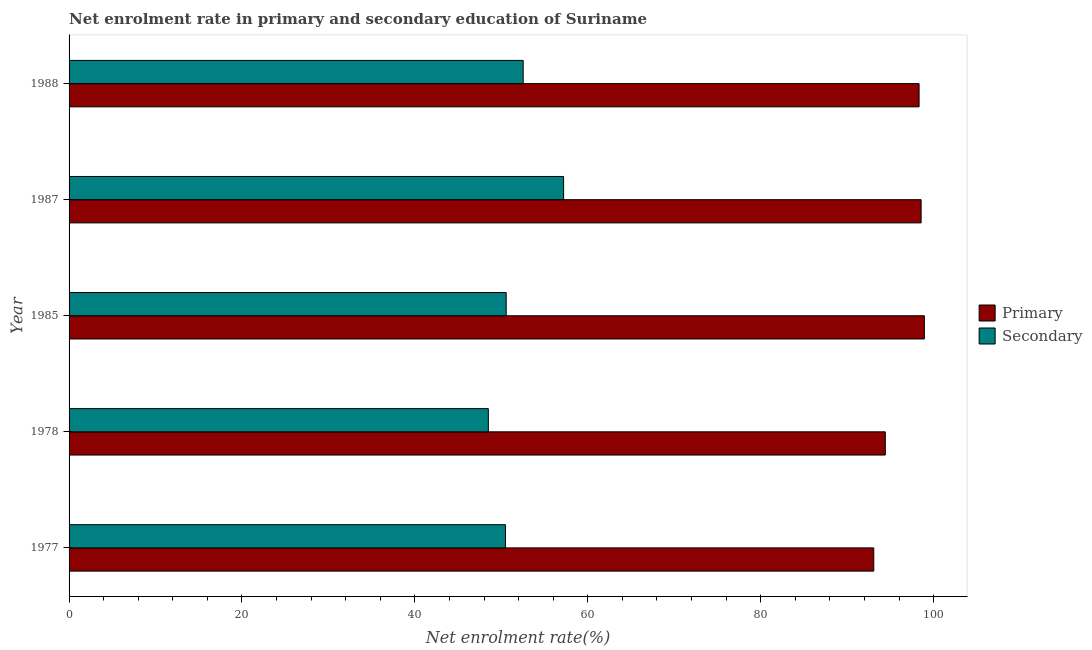How many groups of bars are there?
Provide a succinct answer. 5. Are the number of bars per tick equal to the number of legend labels?
Your answer should be compact. Yes. Are the number of bars on each tick of the Y-axis equal?
Ensure brevity in your answer.  Yes. How many bars are there on the 5th tick from the top?
Make the answer very short. 2. In how many cases, is the number of bars for a given year not equal to the number of legend labels?
Keep it short and to the point. 0. What is the enrollment rate in primary education in 1977?
Provide a short and direct response. 93.08. Across all years, what is the maximum enrollment rate in secondary education?
Offer a very short reply. 57.2. Across all years, what is the minimum enrollment rate in secondary education?
Offer a very short reply. 48.5. In which year was the enrollment rate in primary education minimum?
Your answer should be compact. 1977. What is the total enrollment rate in secondary education in the graph?
Ensure brevity in your answer.  259.26. What is the difference between the enrollment rate in secondary education in 1987 and that in 1988?
Your answer should be very brief. 4.67. What is the difference between the enrollment rate in primary education in 1978 and the enrollment rate in secondary education in 1977?
Offer a terse response. 43.94. What is the average enrollment rate in secondary education per year?
Your answer should be compact. 51.85. In the year 1977, what is the difference between the enrollment rate in secondary education and enrollment rate in primary education?
Ensure brevity in your answer.  -42.6. In how many years, is the enrollment rate in secondary education greater than 8 %?
Your response must be concise. 5. What is the ratio of the enrollment rate in secondary education in 1977 to that in 1978?
Make the answer very short. 1.04. What is the difference between the highest and the second highest enrollment rate in primary education?
Provide a succinct answer. 0.38. What is the difference between the highest and the lowest enrollment rate in secondary education?
Give a very brief answer. 8.71. What does the 2nd bar from the top in 1987 represents?
Provide a succinct answer. Primary. What does the 1st bar from the bottom in 1985 represents?
Make the answer very short. Primary. Are all the bars in the graph horizontal?
Provide a short and direct response. Yes. How many years are there in the graph?
Your answer should be compact. 5. What is the difference between two consecutive major ticks on the X-axis?
Make the answer very short. 20. Are the values on the major ticks of X-axis written in scientific E-notation?
Offer a very short reply. No. Does the graph contain any zero values?
Provide a short and direct response. No. What is the title of the graph?
Your answer should be very brief. Net enrolment rate in primary and secondary education of Suriname. Does "Secondary Education" appear as one of the legend labels in the graph?
Your answer should be very brief. No. What is the label or title of the X-axis?
Provide a succinct answer. Net enrolment rate(%). What is the label or title of the Y-axis?
Your answer should be very brief. Year. What is the Net enrolment rate(%) of Primary in 1977?
Ensure brevity in your answer.  93.08. What is the Net enrolment rate(%) in Secondary in 1977?
Offer a very short reply. 50.47. What is the Net enrolment rate(%) of Primary in 1978?
Provide a short and direct response. 94.41. What is the Net enrolment rate(%) in Secondary in 1978?
Give a very brief answer. 48.5. What is the Net enrolment rate(%) in Primary in 1985?
Provide a succinct answer. 98.93. What is the Net enrolment rate(%) of Secondary in 1985?
Your answer should be very brief. 50.56. What is the Net enrolment rate(%) in Primary in 1987?
Give a very brief answer. 98.55. What is the Net enrolment rate(%) of Secondary in 1987?
Your answer should be very brief. 57.2. What is the Net enrolment rate(%) of Primary in 1988?
Offer a very short reply. 98.32. What is the Net enrolment rate(%) of Secondary in 1988?
Provide a short and direct response. 52.53. Across all years, what is the maximum Net enrolment rate(%) in Primary?
Provide a succinct answer. 98.93. Across all years, what is the maximum Net enrolment rate(%) in Secondary?
Make the answer very short. 57.2. Across all years, what is the minimum Net enrolment rate(%) of Primary?
Make the answer very short. 93.08. Across all years, what is the minimum Net enrolment rate(%) of Secondary?
Your answer should be very brief. 48.5. What is the total Net enrolment rate(%) of Primary in the graph?
Give a very brief answer. 483.28. What is the total Net enrolment rate(%) of Secondary in the graph?
Keep it short and to the point. 259.26. What is the difference between the Net enrolment rate(%) in Primary in 1977 and that in 1978?
Your answer should be very brief. -1.34. What is the difference between the Net enrolment rate(%) in Secondary in 1977 and that in 1978?
Give a very brief answer. 1.98. What is the difference between the Net enrolment rate(%) of Primary in 1977 and that in 1985?
Ensure brevity in your answer.  -5.85. What is the difference between the Net enrolment rate(%) of Secondary in 1977 and that in 1985?
Make the answer very short. -0.09. What is the difference between the Net enrolment rate(%) of Primary in 1977 and that in 1987?
Provide a succinct answer. -5.48. What is the difference between the Net enrolment rate(%) in Secondary in 1977 and that in 1987?
Ensure brevity in your answer.  -6.73. What is the difference between the Net enrolment rate(%) in Primary in 1977 and that in 1988?
Give a very brief answer. -5.24. What is the difference between the Net enrolment rate(%) in Secondary in 1977 and that in 1988?
Give a very brief answer. -2.05. What is the difference between the Net enrolment rate(%) of Primary in 1978 and that in 1985?
Give a very brief answer. -4.52. What is the difference between the Net enrolment rate(%) of Secondary in 1978 and that in 1985?
Make the answer very short. -2.06. What is the difference between the Net enrolment rate(%) in Primary in 1978 and that in 1987?
Provide a short and direct response. -4.14. What is the difference between the Net enrolment rate(%) of Secondary in 1978 and that in 1987?
Offer a terse response. -8.71. What is the difference between the Net enrolment rate(%) of Primary in 1978 and that in 1988?
Offer a terse response. -3.91. What is the difference between the Net enrolment rate(%) in Secondary in 1978 and that in 1988?
Offer a terse response. -4.03. What is the difference between the Net enrolment rate(%) of Primary in 1985 and that in 1987?
Provide a succinct answer. 0.38. What is the difference between the Net enrolment rate(%) of Secondary in 1985 and that in 1987?
Provide a succinct answer. -6.64. What is the difference between the Net enrolment rate(%) in Primary in 1985 and that in 1988?
Provide a succinct answer. 0.61. What is the difference between the Net enrolment rate(%) of Secondary in 1985 and that in 1988?
Offer a terse response. -1.97. What is the difference between the Net enrolment rate(%) in Primary in 1987 and that in 1988?
Ensure brevity in your answer.  0.24. What is the difference between the Net enrolment rate(%) of Secondary in 1987 and that in 1988?
Your answer should be compact. 4.67. What is the difference between the Net enrolment rate(%) in Primary in 1977 and the Net enrolment rate(%) in Secondary in 1978?
Provide a succinct answer. 44.58. What is the difference between the Net enrolment rate(%) in Primary in 1977 and the Net enrolment rate(%) in Secondary in 1985?
Offer a terse response. 42.52. What is the difference between the Net enrolment rate(%) of Primary in 1977 and the Net enrolment rate(%) of Secondary in 1987?
Give a very brief answer. 35.87. What is the difference between the Net enrolment rate(%) of Primary in 1977 and the Net enrolment rate(%) of Secondary in 1988?
Your answer should be compact. 40.55. What is the difference between the Net enrolment rate(%) of Primary in 1978 and the Net enrolment rate(%) of Secondary in 1985?
Give a very brief answer. 43.85. What is the difference between the Net enrolment rate(%) of Primary in 1978 and the Net enrolment rate(%) of Secondary in 1987?
Keep it short and to the point. 37.21. What is the difference between the Net enrolment rate(%) of Primary in 1978 and the Net enrolment rate(%) of Secondary in 1988?
Your answer should be very brief. 41.89. What is the difference between the Net enrolment rate(%) of Primary in 1985 and the Net enrolment rate(%) of Secondary in 1987?
Keep it short and to the point. 41.73. What is the difference between the Net enrolment rate(%) in Primary in 1985 and the Net enrolment rate(%) in Secondary in 1988?
Provide a succinct answer. 46.4. What is the difference between the Net enrolment rate(%) of Primary in 1987 and the Net enrolment rate(%) of Secondary in 1988?
Make the answer very short. 46.03. What is the average Net enrolment rate(%) in Primary per year?
Make the answer very short. 96.66. What is the average Net enrolment rate(%) of Secondary per year?
Provide a succinct answer. 51.85. In the year 1977, what is the difference between the Net enrolment rate(%) of Primary and Net enrolment rate(%) of Secondary?
Offer a terse response. 42.6. In the year 1978, what is the difference between the Net enrolment rate(%) in Primary and Net enrolment rate(%) in Secondary?
Offer a terse response. 45.92. In the year 1985, what is the difference between the Net enrolment rate(%) of Primary and Net enrolment rate(%) of Secondary?
Ensure brevity in your answer.  48.37. In the year 1987, what is the difference between the Net enrolment rate(%) in Primary and Net enrolment rate(%) in Secondary?
Offer a very short reply. 41.35. In the year 1988, what is the difference between the Net enrolment rate(%) of Primary and Net enrolment rate(%) of Secondary?
Make the answer very short. 45.79. What is the ratio of the Net enrolment rate(%) of Primary in 1977 to that in 1978?
Give a very brief answer. 0.99. What is the ratio of the Net enrolment rate(%) in Secondary in 1977 to that in 1978?
Provide a succinct answer. 1.04. What is the ratio of the Net enrolment rate(%) in Primary in 1977 to that in 1985?
Your response must be concise. 0.94. What is the ratio of the Net enrolment rate(%) of Primary in 1977 to that in 1987?
Offer a very short reply. 0.94. What is the ratio of the Net enrolment rate(%) in Secondary in 1977 to that in 1987?
Your response must be concise. 0.88. What is the ratio of the Net enrolment rate(%) of Primary in 1977 to that in 1988?
Offer a terse response. 0.95. What is the ratio of the Net enrolment rate(%) in Secondary in 1977 to that in 1988?
Make the answer very short. 0.96. What is the ratio of the Net enrolment rate(%) in Primary in 1978 to that in 1985?
Offer a terse response. 0.95. What is the ratio of the Net enrolment rate(%) of Secondary in 1978 to that in 1985?
Give a very brief answer. 0.96. What is the ratio of the Net enrolment rate(%) of Primary in 1978 to that in 1987?
Give a very brief answer. 0.96. What is the ratio of the Net enrolment rate(%) of Secondary in 1978 to that in 1987?
Keep it short and to the point. 0.85. What is the ratio of the Net enrolment rate(%) in Primary in 1978 to that in 1988?
Keep it short and to the point. 0.96. What is the ratio of the Net enrolment rate(%) of Secondary in 1978 to that in 1988?
Your answer should be very brief. 0.92. What is the ratio of the Net enrolment rate(%) in Secondary in 1985 to that in 1987?
Offer a terse response. 0.88. What is the ratio of the Net enrolment rate(%) in Primary in 1985 to that in 1988?
Offer a terse response. 1.01. What is the ratio of the Net enrolment rate(%) in Secondary in 1985 to that in 1988?
Provide a succinct answer. 0.96. What is the ratio of the Net enrolment rate(%) in Secondary in 1987 to that in 1988?
Make the answer very short. 1.09. What is the difference between the highest and the second highest Net enrolment rate(%) in Primary?
Your answer should be very brief. 0.38. What is the difference between the highest and the second highest Net enrolment rate(%) of Secondary?
Offer a very short reply. 4.67. What is the difference between the highest and the lowest Net enrolment rate(%) of Primary?
Your answer should be very brief. 5.85. What is the difference between the highest and the lowest Net enrolment rate(%) in Secondary?
Provide a succinct answer. 8.71. 